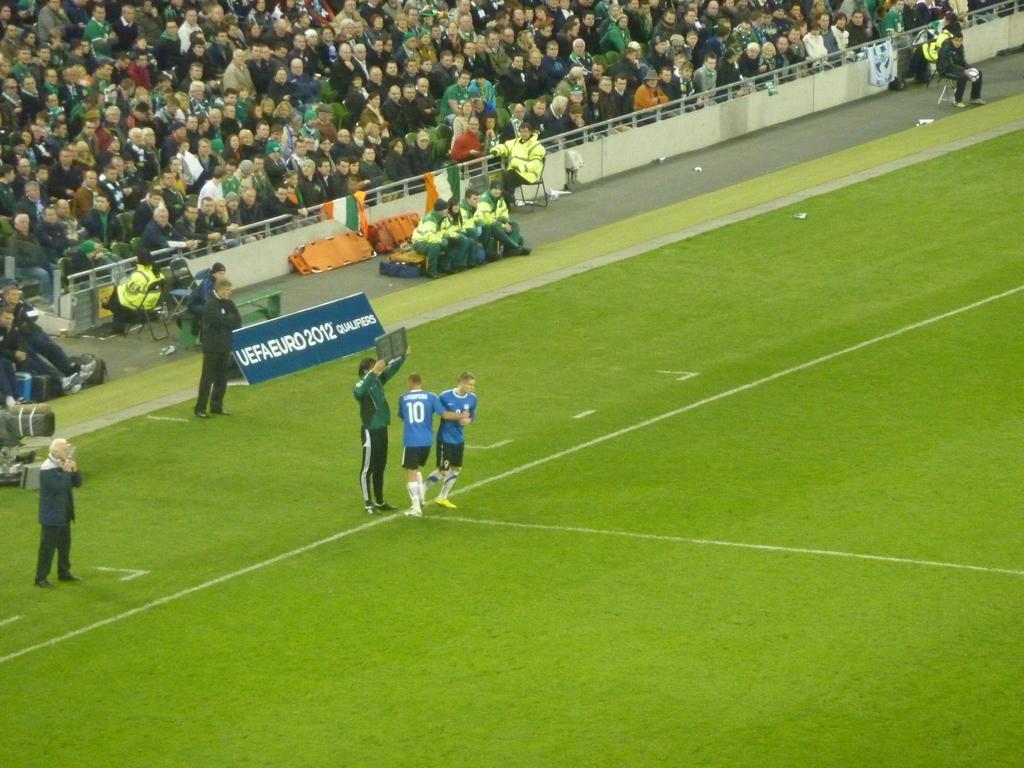In one or two sentences, can you explain what this image depicts? In the center of the image we can see people standing. In the background there is crowd sitting and there is a fence we can see flags. 